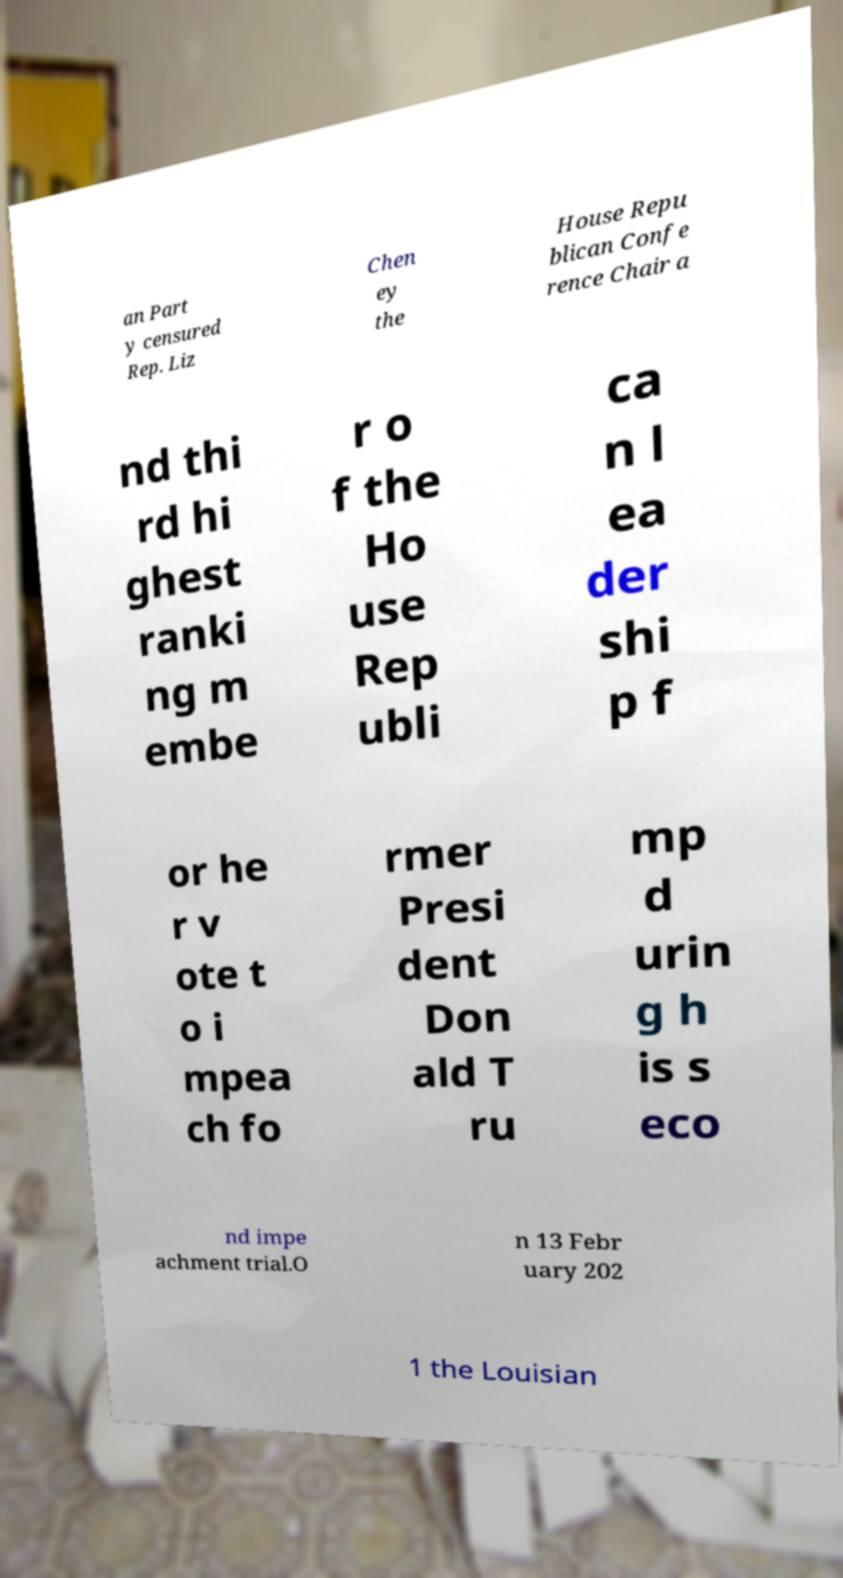Can you accurately transcribe the text from the provided image for me? an Part y censured Rep. Liz Chen ey the House Repu blican Confe rence Chair a nd thi rd hi ghest ranki ng m embe r o f the Ho use Rep ubli ca n l ea der shi p f or he r v ote t o i mpea ch fo rmer Presi dent Don ald T ru mp d urin g h is s eco nd impe achment trial.O n 13 Febr uary 202 1 the Louisian 